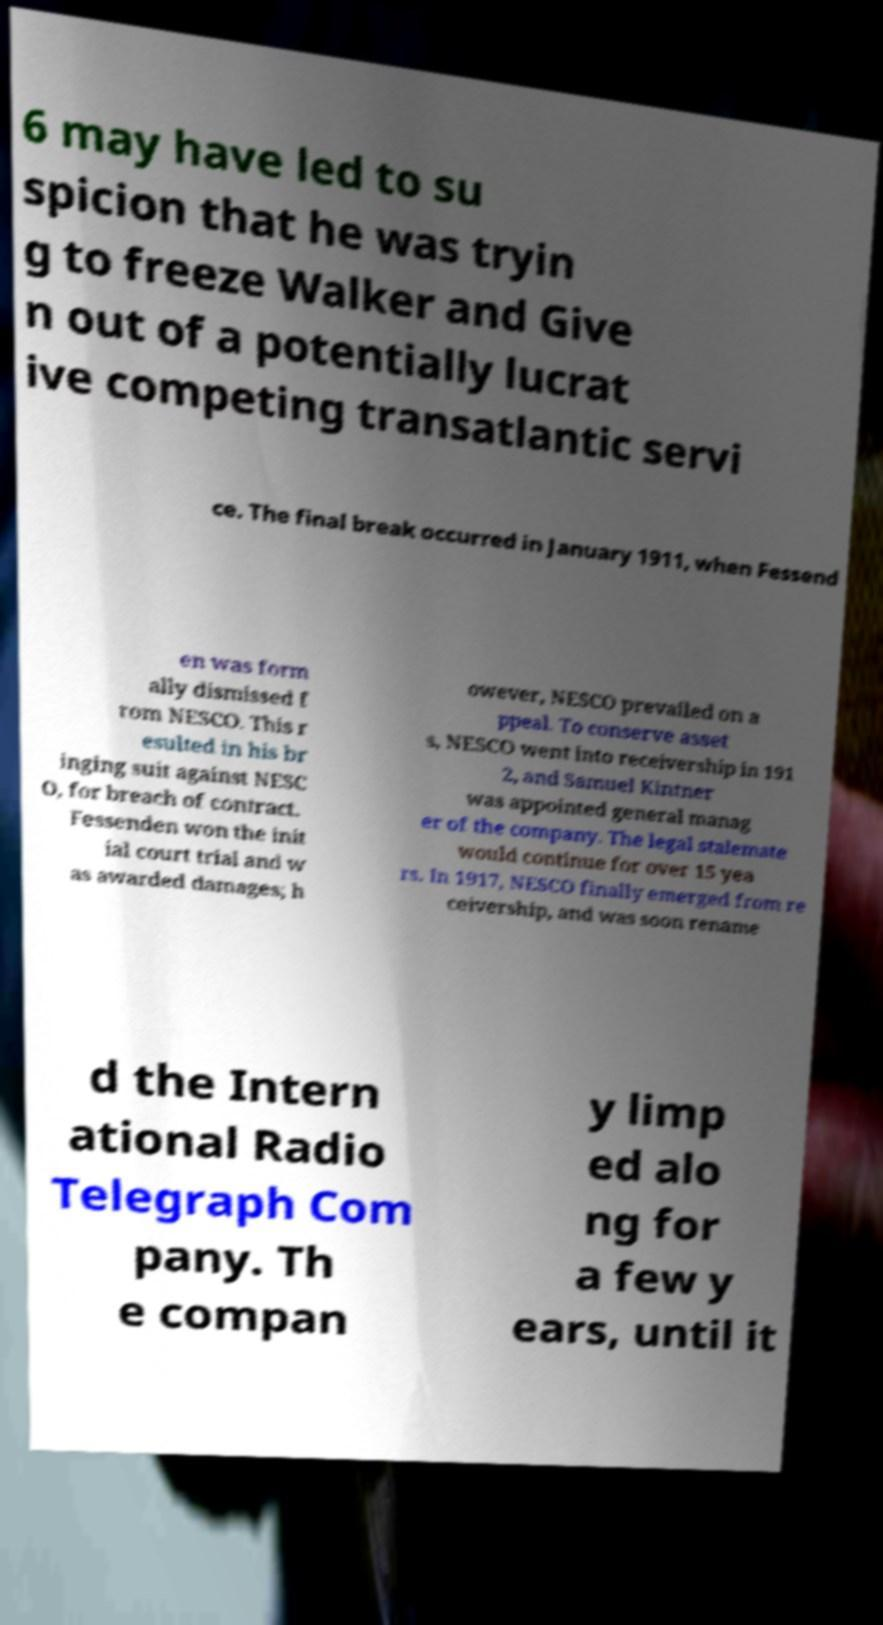Can you read and provide the text displayed in the image?This photo seems to have some interesting text. Can you extract and type it out for me? 6 may have led to su spicion that he was tryin g to freeze Walker and Give n out of a potentially lucrat ive competing transatlantic servi ce. The final break occurred in January 1911, when Fessend en was form ally dismissed f rom NESCO. This r esulted in his br inging suit against NESC O, for breach of contract. Fessenden won the init ial court trial and w as awarded damages; h owever, NESCO prevailed on a ppeal. To conserve asset s, NESCO went into receivership in 191 2, and Samuel Kintner was appointed general manag er of the company. The legal stalemate would continue for over 15 yea rs. In 1917, NESCO finally emerged from re ceivership, and was soon rename d the Intern ational Radio Telegraph Com pany. Th e compan y limp ed alo ng for a few y ears, until it 